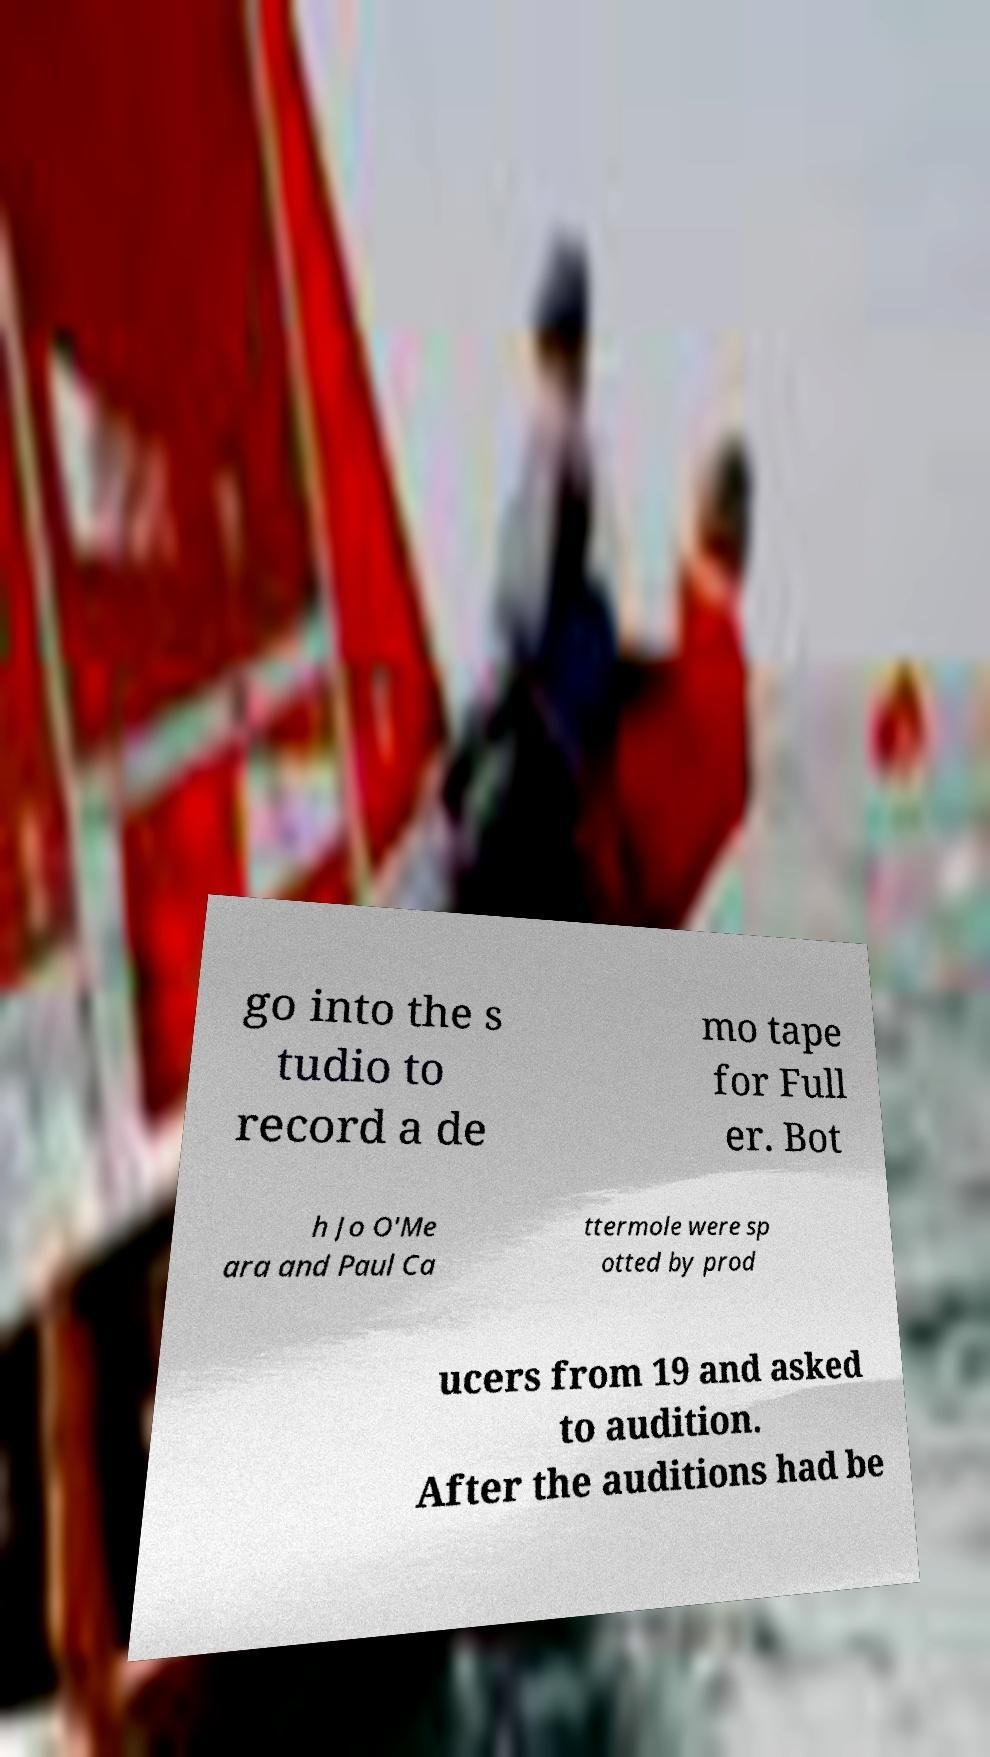Please identify and transcribe the text found in this image. go into the s tudio to record a de mo tape for Full er. Bot h Jo O'Me ara and Paul Ca ttermole were sp otted by prod ucers from 19 and asked to audition. After the auditions had be 